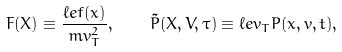Convert formula to latex. <formula><loc_0><loc_0><loc_500><loc_500>F ( X ) \equiv \frac { \ell e f ( x ) } { m v _ { T } ^ { 2 } } , \quad \tilde { P } ( X , V , \tau ) \equiv \ell e v _ { T } P ( x , v , t ) ,</formula> 